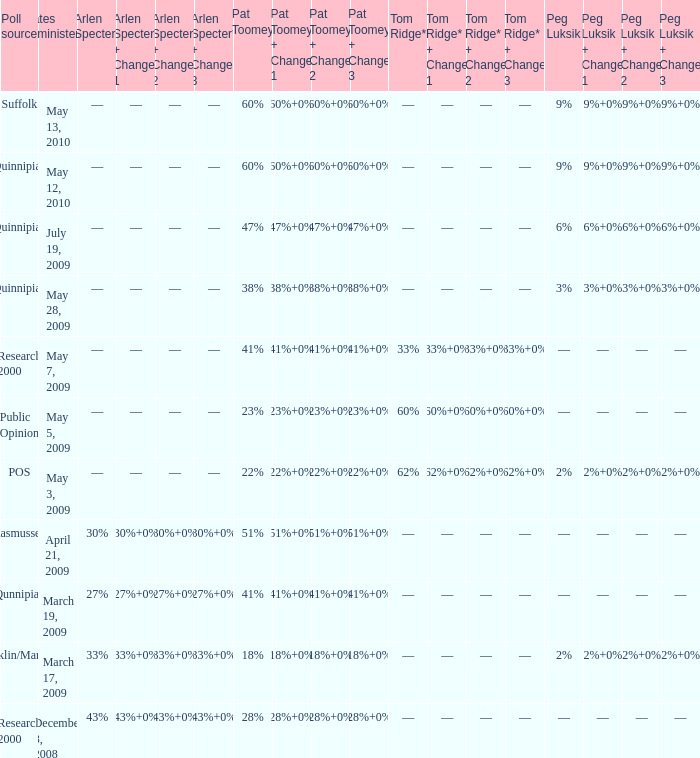Which Tom Ridge* has a Pat Toomey of 60%, and a Poll source of suffolk? ––. 